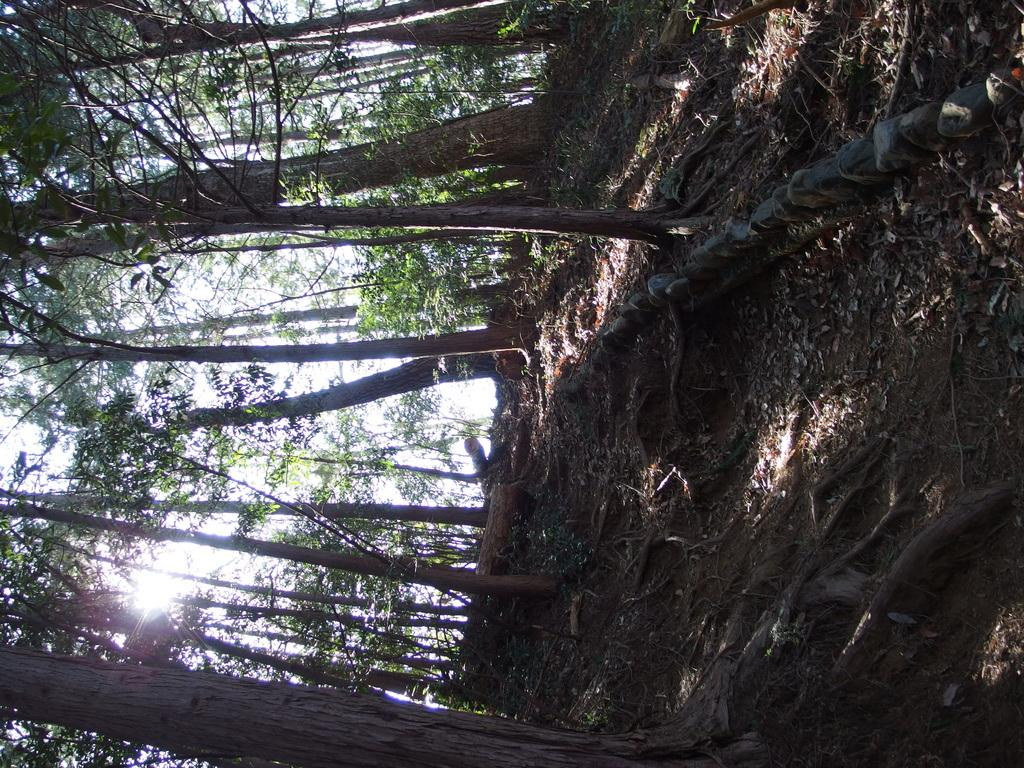What type of vegetation is present in the image? There are trees with branches and leaves in the image. What other natural elements can be seen in the image? There are rocks visible in the image. Where are the roots of the trees located in the image? The roots of the trees are on the ground in the image. What part of the tree is visible besides the branches and leaves? There is a tree trunk in the image}. What type of flower is blooming on the tree in the image? There are no flowers visible on the trees in the image. Can you hear the bell ringing in the image? There is no bell present in the image. 